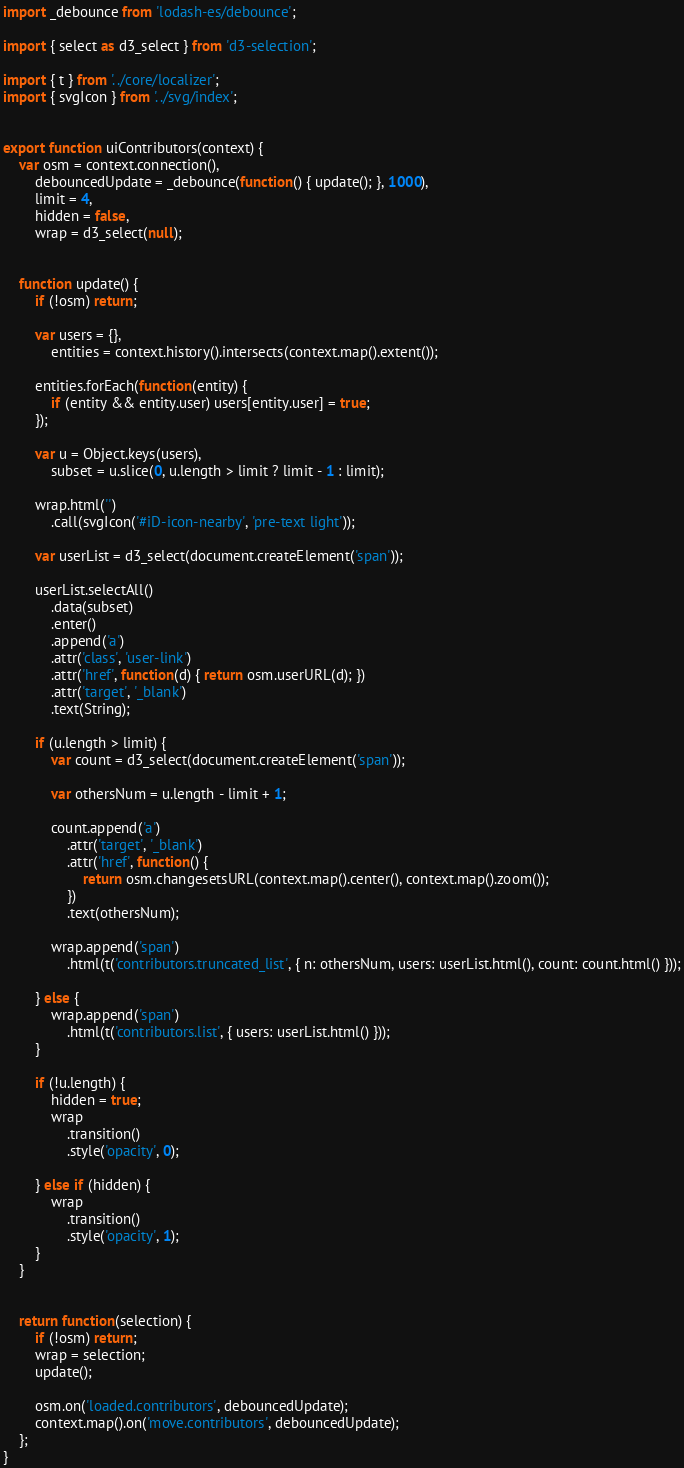<code> <loc_0><loc_0><loc_500><loc_500><_JavaScript_>import _debounce from 'lodash-es/debounce';

import { select as d3_select } from 'd3-selection';

import { t } from '../core/localizer';
import { svgIcon } from '../svg/index';


export function uiContributors(context) {
    var osm = context.connection(),
        debouncedUpdate = _debounce(function() { update(); }, 1000),
        limit = 4,
        hidden = false,
        wrap = d3_select(null);


    function update() {
        if (!osm) return;

        var users = {},
            entities = context.history().intersects(context.map().extent());

        entities.forEach(function(entity) {
            if (entity && entity.user) users[entity.user] = true;
        });

        var u = Object.keys(users),
            subset = u.slice(0, u.length > limit ? limit - 1 : limit);

        wrap.html('')
            .call(svgIcon('#iD-icon-nearby', 'pre-text light'));

        var userList = d3_select(document.createElement('span'));

        userList.selectAll()
            .data(subset)
            .enter()
            .append('a')
            .attr('class', 'user-link')
            .attr('href', function(d) { return osm.userURL(d); })
            .attr('target', '_blank')
            .text(String);

        if (u.length > limit) {
            var count = d3_select(document.createElement('span'));

            var othersNum = u.length - limit + 1;

            count.append('a')
                .attr('target', '_blank')
                .attr('href', function() {
                    return osm.changesetsURL(context.map().center(), context.map().zoom());
                })
                .text(othersNum);

            wrap.append('span')
                .html(t('contributors.truncated_list', { n: othersNum, users: userList.html(), count: count.html() }));

        } else {
            wrap.append('span')
                .html(t('contributors.list', { users: userList.html() }));
        }

        if (!u.length) {
            hidden = true;
            wrap
                .transition()
                .style('opacity', 0);

        } else if (hidden) {
            wrap
                .transition()
                .style('opacity', 1);
        }
    }


    return function(selection) {
        if (!osm) return;
        wrap = selection;
        update();

        osm.on('loaded.contributors', debouncedUpdate);
        context.map().on('move.contributors', debouncedUpdate);
    };
}
</code> 